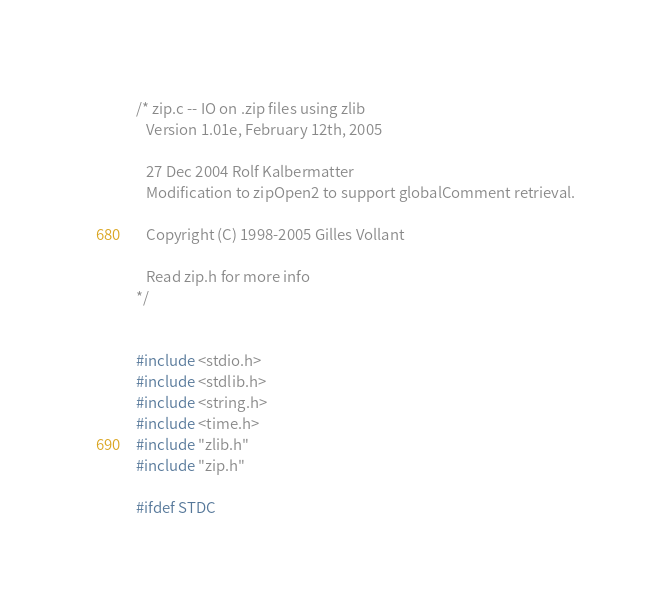<code> <loc_0><loc_0><loc_500><loc_500><_C_>/* zip.c -- IO on .zip files using zlib
   Version 1.01e, February 12th, 2005

   27 Dec 2004 Rolf Kalbermatter
   Modification to zipOpen2 to support globalComment retrieval.

   Copyright (C) 1998-2005 Gilles Vollant

   Read zip.h for more info
*/


#include <stdio.h>
#include <stdlib.h>
#include <string.h>
#include <time.h>
#include "zlib.h"
#include "zip.h"

#ifdef STDC</code> 